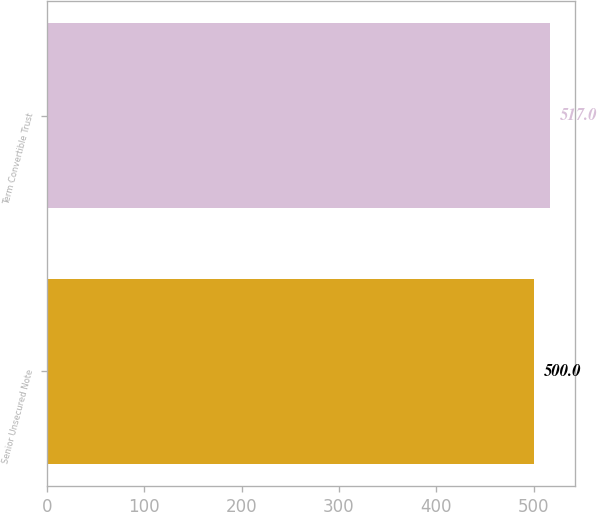<chart> <loc_0><loc_0><loc_500><loc_500><bar_chart><fcel>Senior Unsecured Note<fcel>Term Convertible Trust<nl><fcel>500<fcel>517<nl></chart> 